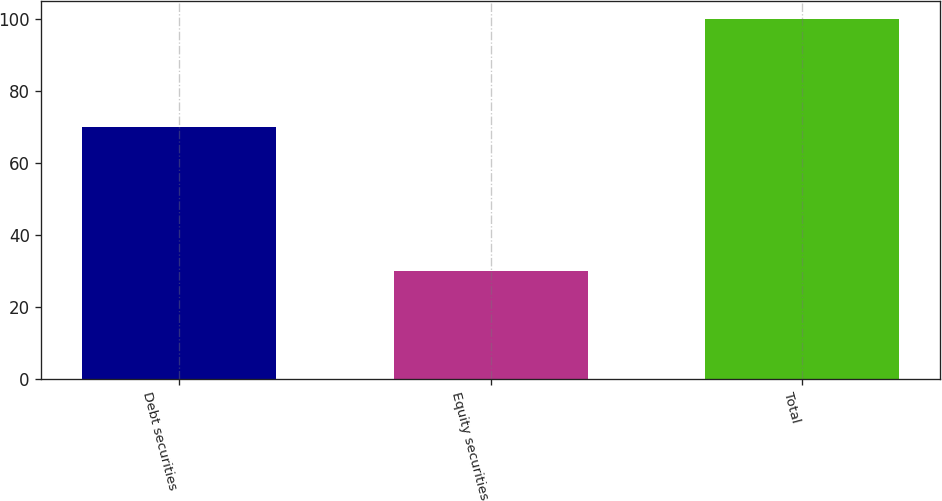Convert chart. <chart><loc_0><loc_0><loc_500><loc_500><bar_chart><fcel>Debt securities<fcel>Equity securities<fcel>Total<nl><fcel>70<fcel>30<fcel>100<nl></chart> 